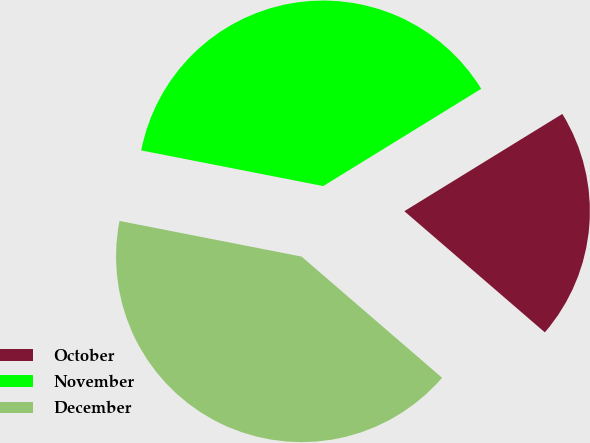<chart> <loc_0><loc_0><loc_500><loc_500><pie_chart><fcel>October<fcel>November<fcel>December<nl><fcel>20.11%<fcel>38.14%<fcel>41.75%<nl></chart> 